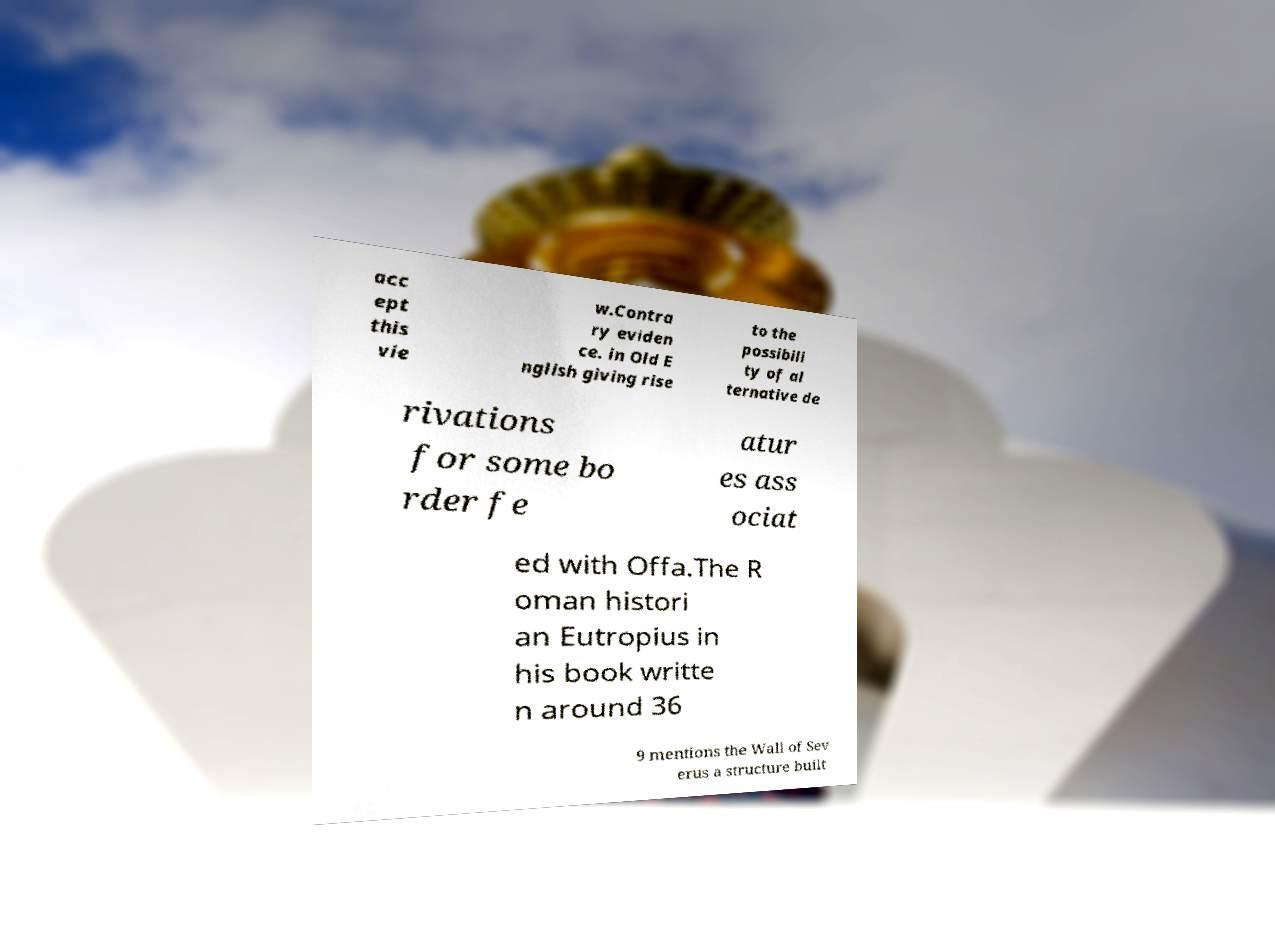Can you accurately transcribe the text from the provided image for me? acc ept this vie w.Contra ry eviden ce. in Old E nglish giving rise to the possibili ty of al ternative de rivations for some bo rder fe atur es ass ociat ed with Offa.The R oman histori an Eutropius in his book writte n around 36 9 mentions the Wall of Sev erus a structure built 